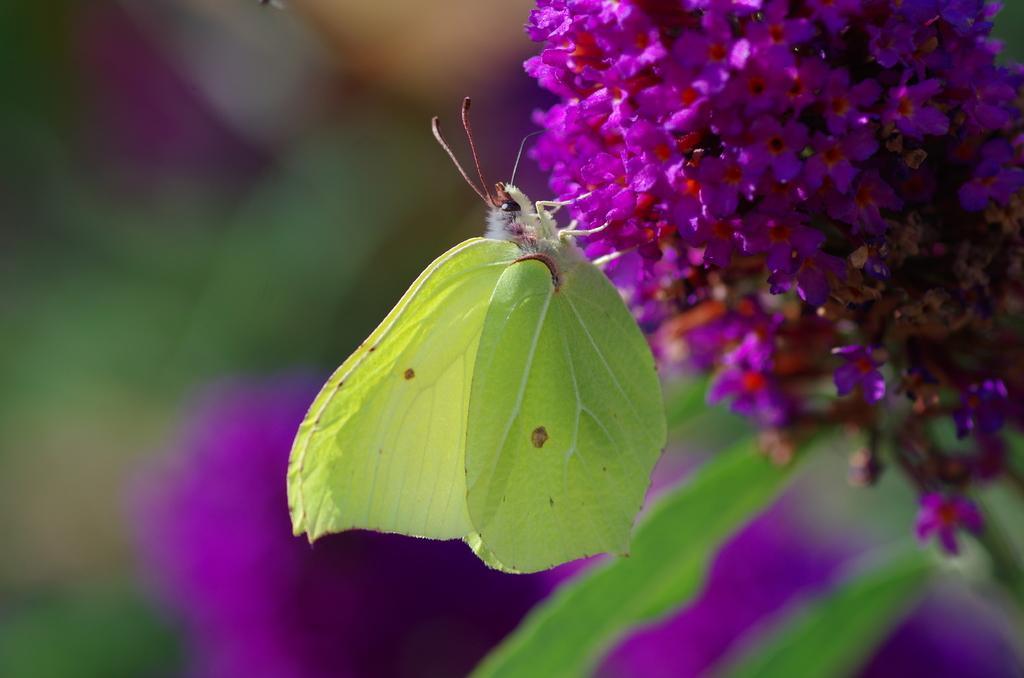Describe this image in one or two sentences. In this image there is a green color fly on the flowers and the background is blurry. 